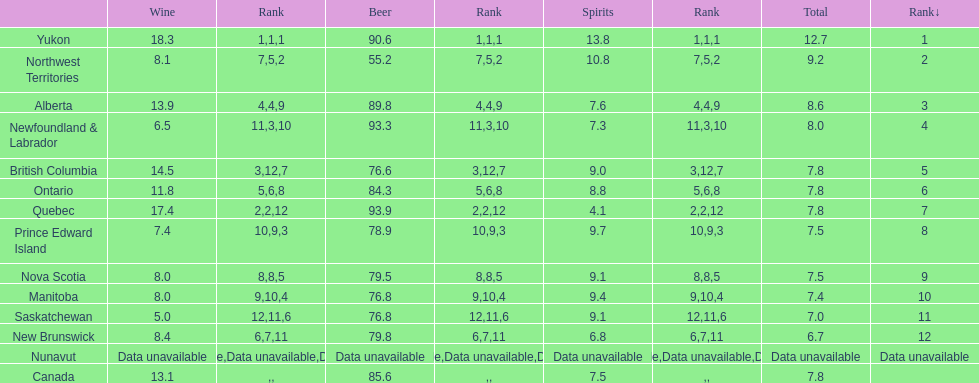Quebec had a beer usage of 9 4.1. 